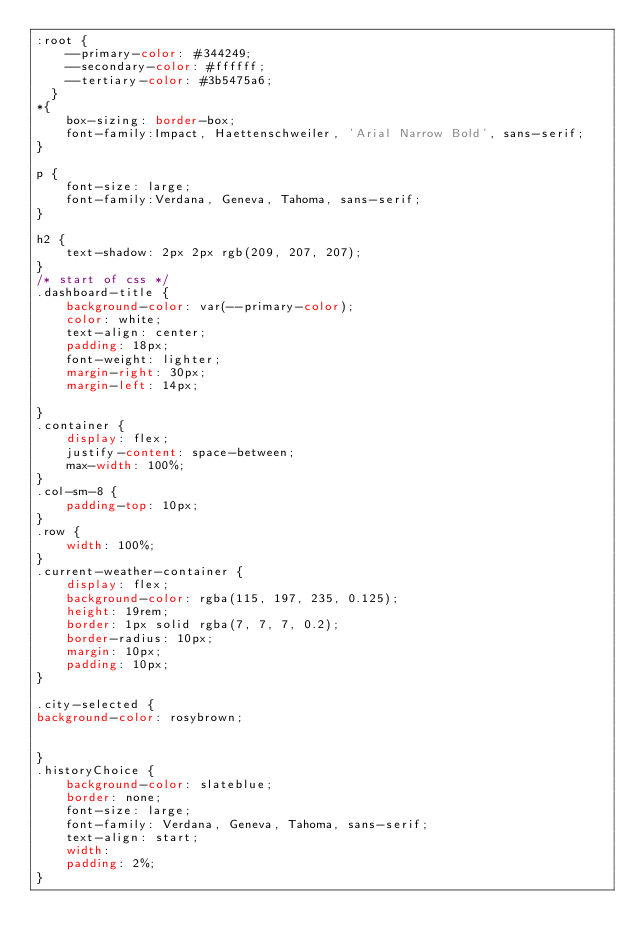Convert code to text. <code><loc_0><loc_0><loc_500><loc_500><_CSS_>:root {
    --primary-color: #344249;
    --secondary-color: #ffffff;
    --tertiary-color: #3b5475a6;
  }
*{
    box-sizing: border-box;
    font-family:Impact, Haettenschweiler, 'Arial Narrow Bold', sans-serif;
}

p {
    font-size: large;
    font-family:Verdana, Geneva, Tahoma, sans-serif;
}

h2 {
    text-shadow: 2px 2px rgb(209, 207, 207);
}
/* start of css */
.dashboard-title {
    background-color: var(--primary-color);
    color: white;
    text-align: center;
    padding: 18px;
    font-weight: lighter;
    margin-right: 30px;
    margin-left: 14px;

}
.container {
    display: flex;
    justify-content: space-between;
    max-width: 100%;
}
.col-sm-8 {
    padding-top: 10px;
}
.row {
    width: 100%;
}
.current-weather-container {
    display: flex;
    background-color: rgba(115, 197, 235, 0.125);
    height: 19rem;
    border: 1px solid rgba(7, 7, 7, 0.2);
    border-radius: 10px;
    margin: 10px;
    padding: 10px;
}

.city-selected {
background-color: rosybrown;


}
.historyChoice {
    background-color: slateblue;
    border: none;
    font-size: large;
    font-family: Verdana, Geneva, Tahoma, sans-serif;
    text-align: start;
    width:
    padding: 2%;
}

</code> 